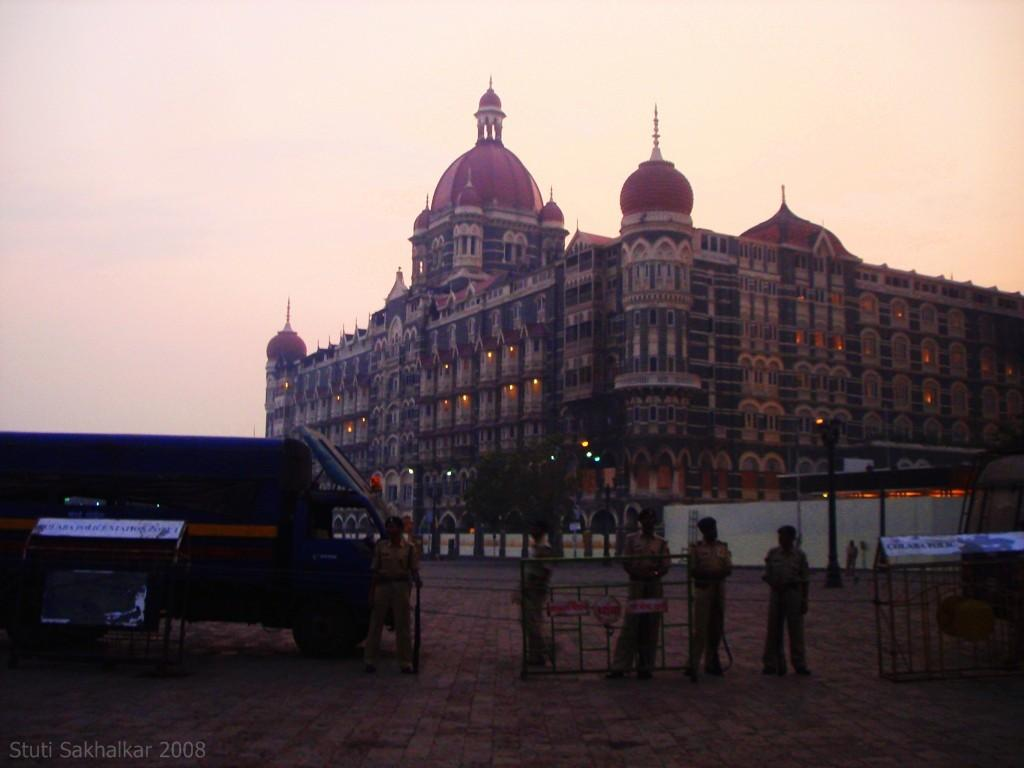What is the main structure in the image? There is a big building in the image. What are the people doing on the road in the image? Cops are standing on the road in the image. What type of vehicle can be seen in the image? There is a blue van in the image. What is visible at the top of the image? The sky is visible at the top of the image. Can you tell me how many letters are floating in the river in the image? There is no river present in the image, and therefore no letters can be seen floating in it. What type of sink is visible in the image? There is no sink present in the image. 